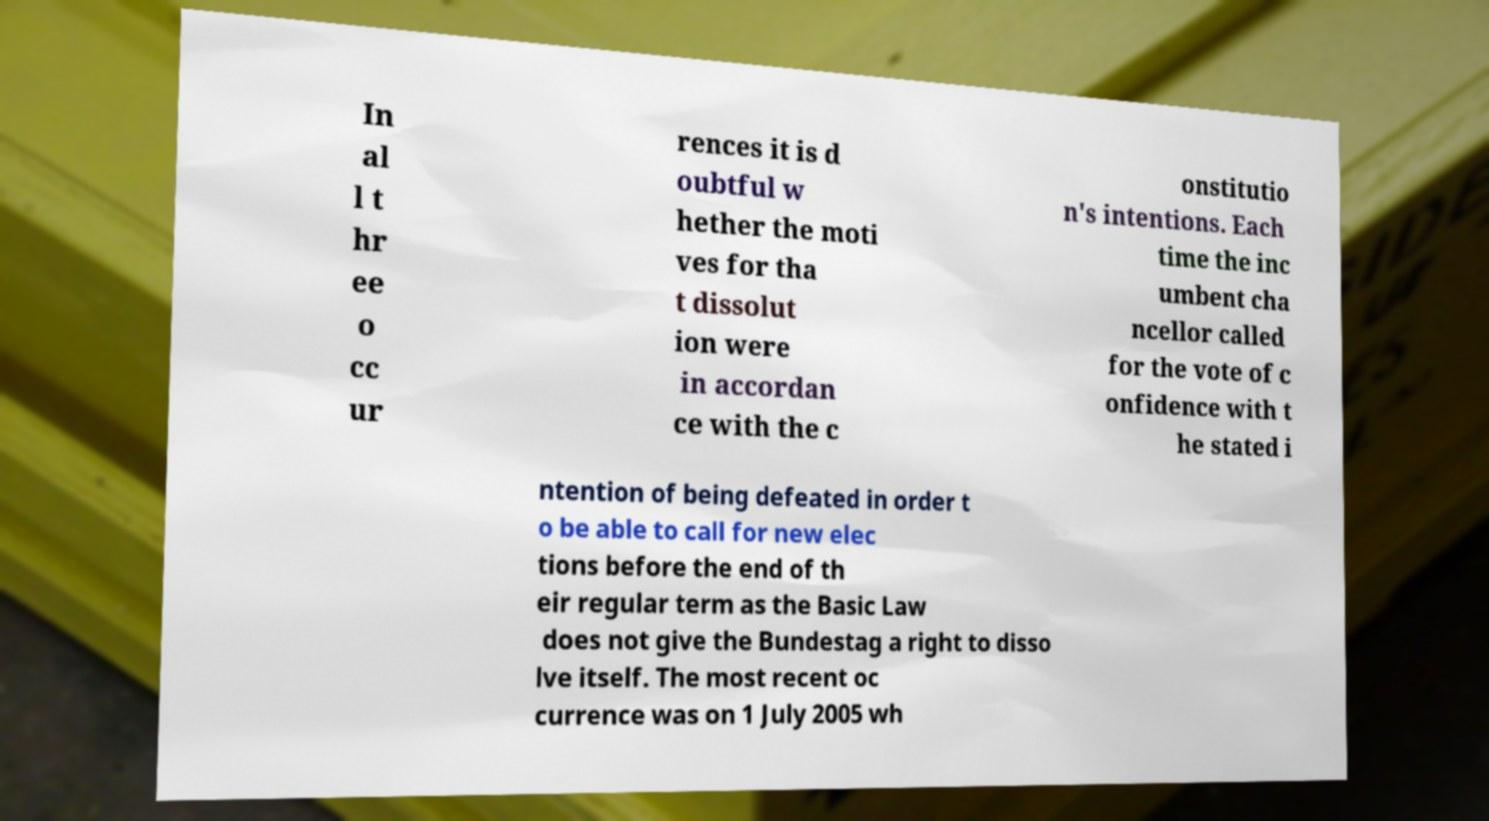Could you extract and type out the text from this image? In al l t hr ee o cc ur rences it is d oubtful w hether the moti ves for tha t dissolut ion were in accordan ce with the c onstitutio n's intentions. Each time the inc umbent cha ncellor called for the vote of c onfidence with t he stated i ntention of being defeated in order t o be able to call for new elec tions before the end of th eir regular term as the Basic Law does not give the Bundestag a right to disso lve itself. The most recent oc currence was on 1 July 2005 wh 